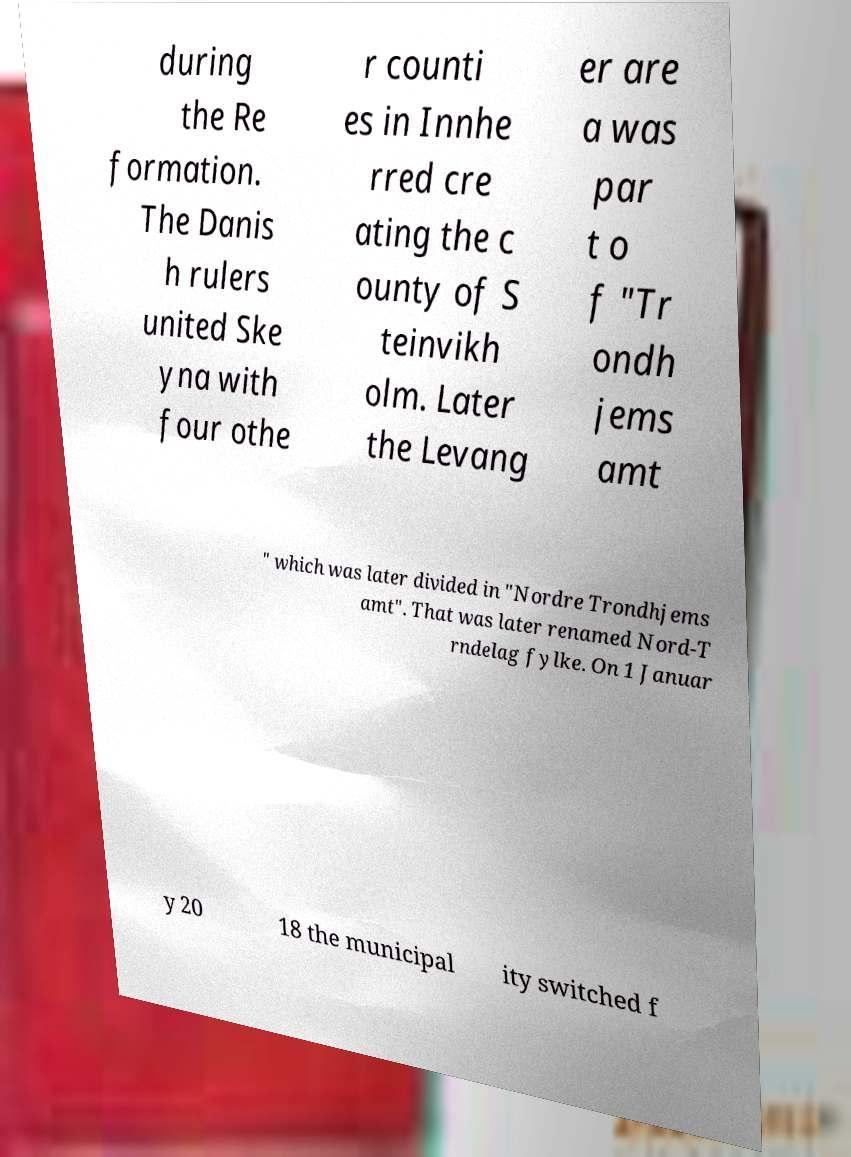What messages or text are displayed in this image? I need them in a readable, typed format. during the Re formation. The Danis h rulers united Ske yna with four othe r counti es in Innhe rred cre ating the c ounty of S teinvikh olm. Later the Levang er are a was par t o f "Tr ondh jems amt " which was later divided in "Nordre Trondhjems amt". That was later renamed Nord-T rndelag fylke. On 1 Januar y 20 18 the municipal ity switched f 